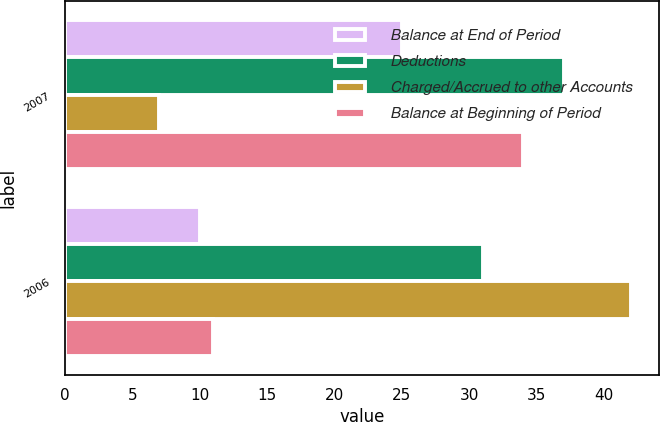Convert chart. <chart><loc_0><loc_0><loc_500><loc_500><stacked_bar_chart><ecel><fcel>2007<fcel>2006<nl><fcel>Balance at End of Period<fcel>25<fcel>10<nl><fcel>Deductions<fcel>37<fcel>31<nl><fcel>Charged/Accrued to other Accounts<fcel>7<fcel>42<nl><fcel>Balance at Beginning of Period<fcel>34<fcel>11<nl></chart> 